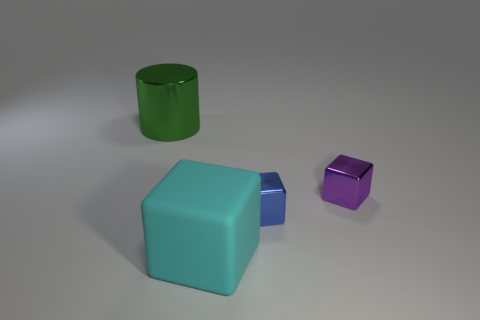Is there any other thing that is the same color as the large metal object? Upon review, there are no other objects in the image that match the exact shade of the large teal metal cube. However, the smaller blue cube shares a similar color hue but is not identical. 